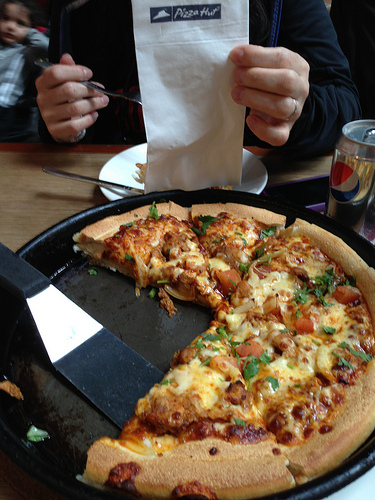Please provide the bounding box coordinate of the region this sentence describes: a spatula to pick up the pizza slices. The spatula to pick up the pizza slices can be seen within the coordinates [0.14, 0.52, 0.44, 0.82]. 